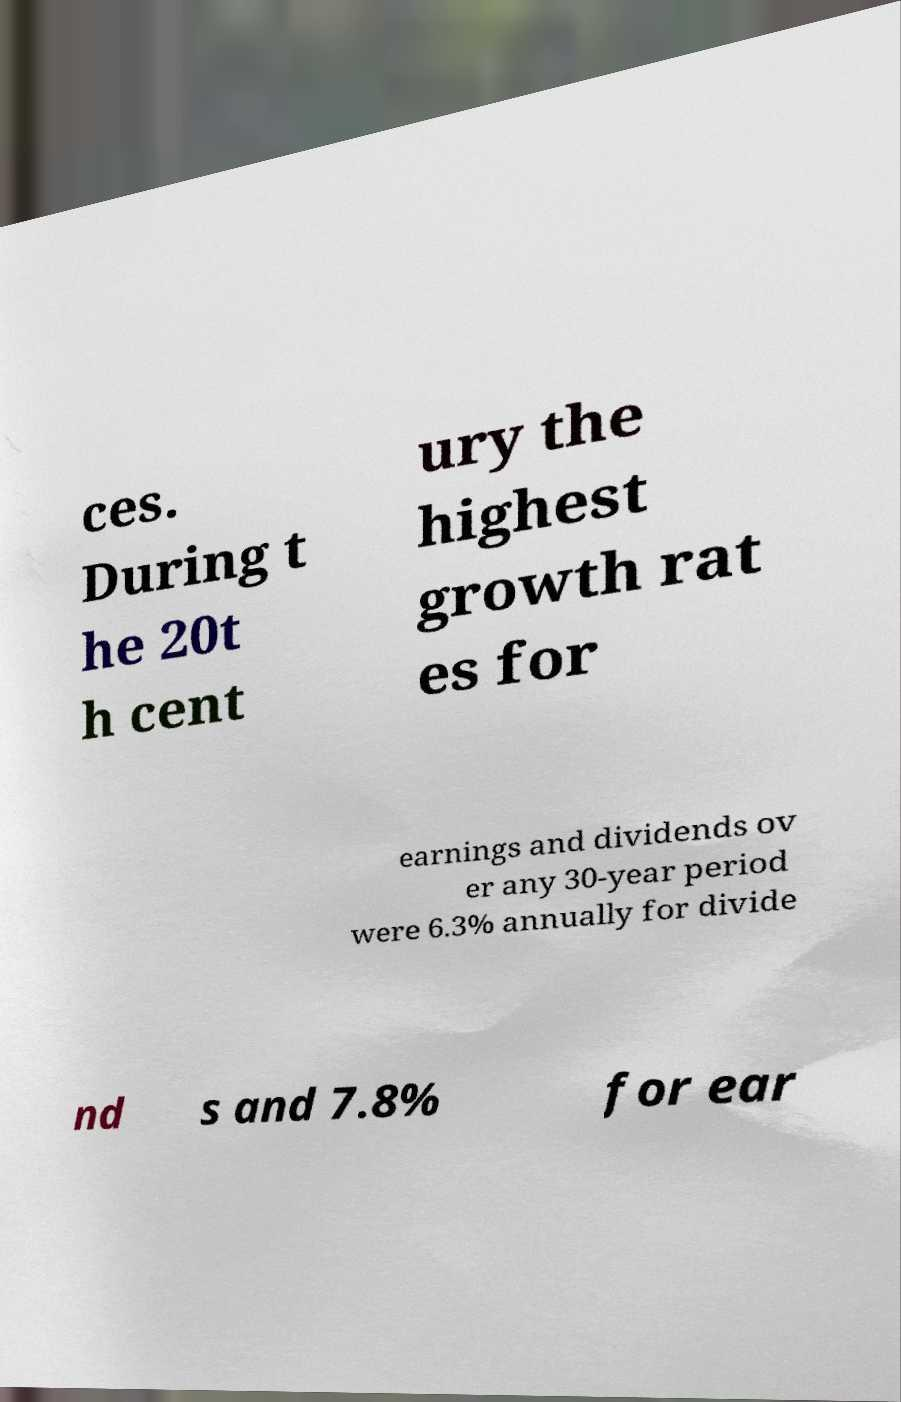Can you read and provide the text displayed in the image?This photo seems to have some interesting text. Can you extract and type it out for me? ces. During t he 20t h cent ury the highest growth rat es for earnings and dividends ov er any 30-year period were 6.3% annually for divide nd s and 7.8% for ear 